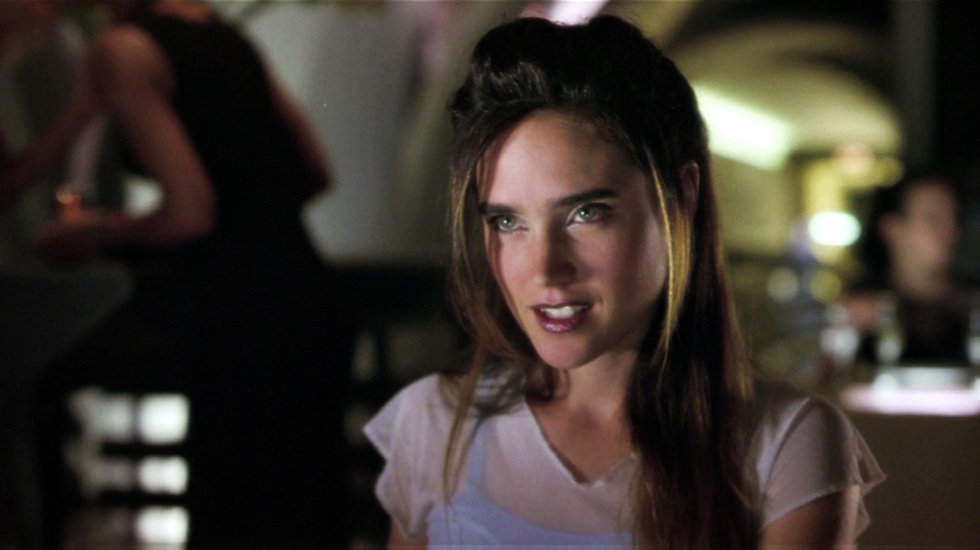Describe the following image. The image shows a woman who appears to be seated in a bar or similar social venue. She wears a casual white top and her hair is styled with strands framing her face. Her expression is slightly amused with a gentle smile, suggesting that she might be enjoying a conversation or an entertaining observation. The background, slightly out of focus, indicates a dimly lit setting that speaks to the ambiance commonly found in bars or restaurants. The overall image captures a candid and personal moment, akin to a scene one might find in a social or public setting. 